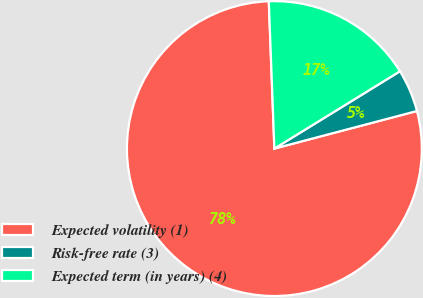<chart> <loc_0><loc_0><loc_500><loc_500><pie_chart><fcel>Expected volatility (1)<fcel>Risk-free rate (3)<fcel>Expected term (in years) (4)<nl><fcel>78.5%<fcel>4.68%<fcel>16.82%<nl></chart> 